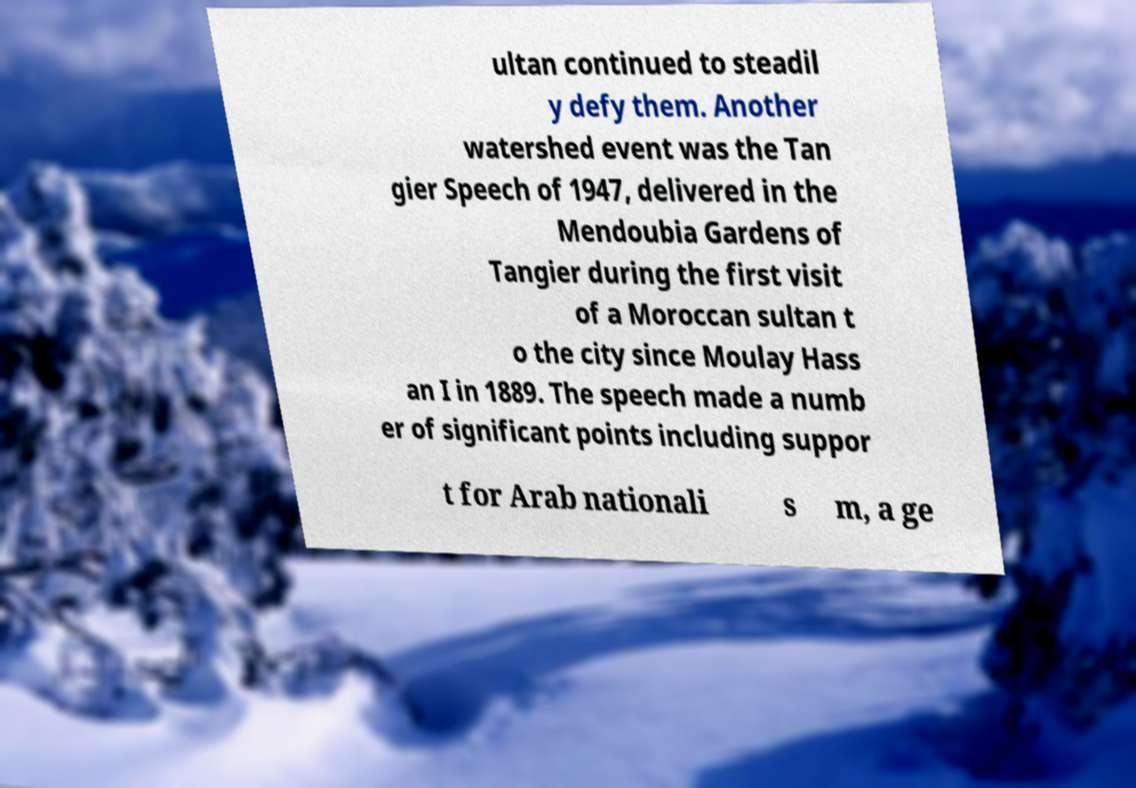Could you assist in decoding the text presented in this image and type it out clearly? ultan continued to steadil y defy them. Another watershed event was the Tan gier Speech of 1947, delivered in the Mendoubia Gardens of Tangier during the first visit of a Moroccan sultan t o the city since Moulay Hass an I in 1889. The speech made a numb er of significant points including suppor t for Arab nationali s m, a ge 